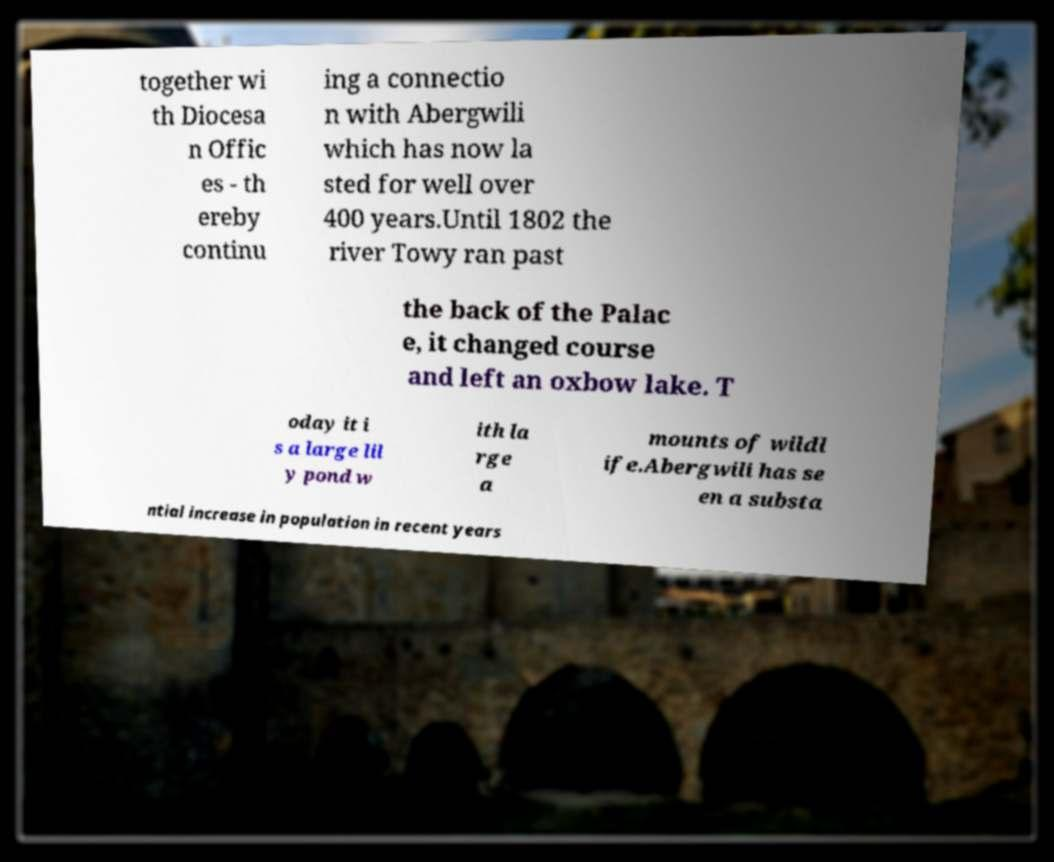Can you accurately transcribe the text from the provided image for me? together wi th Diocesa n Offic es - th ereby continu ing a connectio n with Abergwili which has now la sted for well over 400 years.Until 1802 the river Towy ran past the back of the Palac e, it changed course and left an oxbow lake. T oday it i s a large lil y pond w ith la rge a mounts of wildl ife.Abergwili has se en a substa ntial increase in population in recent years 